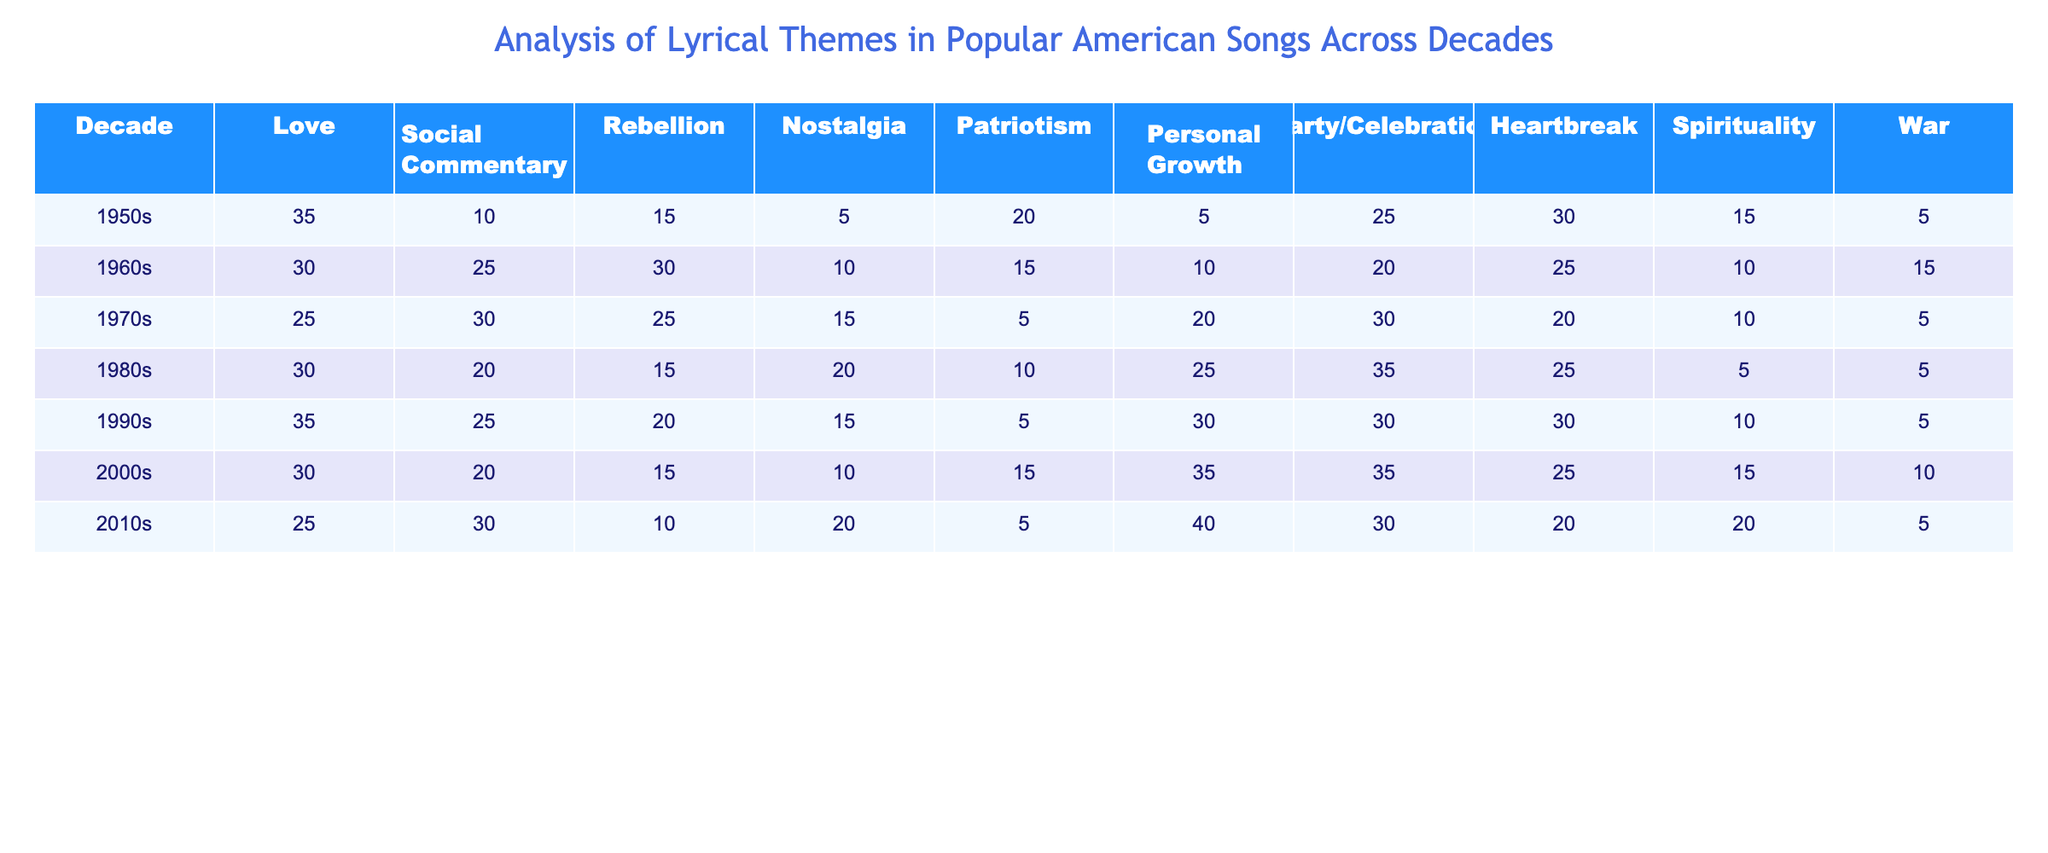What is the theme with the highest value in the 1960s? In the 1960s, the themes are listed with values. The highest value among all themes is 30, which corresponds to both Rebellion and Social Commentary.
Answer: Social Commentary or Rebellion Which decade shows the most significant growth in the theme of Personal Growth? By examining the values for Personal Growth across the decades, the highest value is 40 in the 2010s, while the lowest is 5 in the 1950s. The difference is 40 - 5 = 35, indicating significant growth.
Answer: 35 What is the average value of the Love theme across all decades? To find the average, we sum the values for Love across the decades: (35 + 30 + 25 + 30 + 35 + 30 + 25) = 210. There are 7 decades, so the average is 210/7 = 30.
Answer: 30 Is there a decade where War is a significant theme (greater than 10)? By checking each decade's War theme values, we find that the only decade with a value greater than 10 is the 1960s, where the value is 15.
Answer: Yes Which two decades have the same value for Party/Celebration? Looking at the Party/Celebration theme values, the 1980s and 2000s both have a value of 35.
Answer: 1980s and 2000s What is the total value for Nostalgia across all decades? The Nostalgia values are added together: (5 + 10 + 15 + 20 + 15 + 10 + 20) = 105.
Answer: 105 In which decade did Patriotism decline the most compared to the previous decade? Observing the Patriotism values: 20 (1950s), 15 (1960s), 5 (1970s), 10 (1980s), 5 (1990s), 15 (2000s), 5 (2010s). The greatest decline is from 20 in the 1950s to 15 in the 1960s.
Answer: From 20 to 15 What is the difference between the highest Heartbreak and the lowest Heartbreak values? The maximum Heartbreak value is 35 from the 1980s, while the minimum is 20 from the 2010s. The difference is 35 - 20 = 15.
Answer: 15 Which theme has consistently low values throughout the decades, and what is its highest value? The theme with consistently low values is War, with values of 5, 15, 5, 5, 5, 10, and 5. Its highest value is 15 in the 1960s.
Answer: 15 Which decade has the lowest value for Social Commentary, and what is that value? Looking at the Social Commentary values, the lowest is 10, which occurs in the 1950s and 2000s.
Answer: 10 